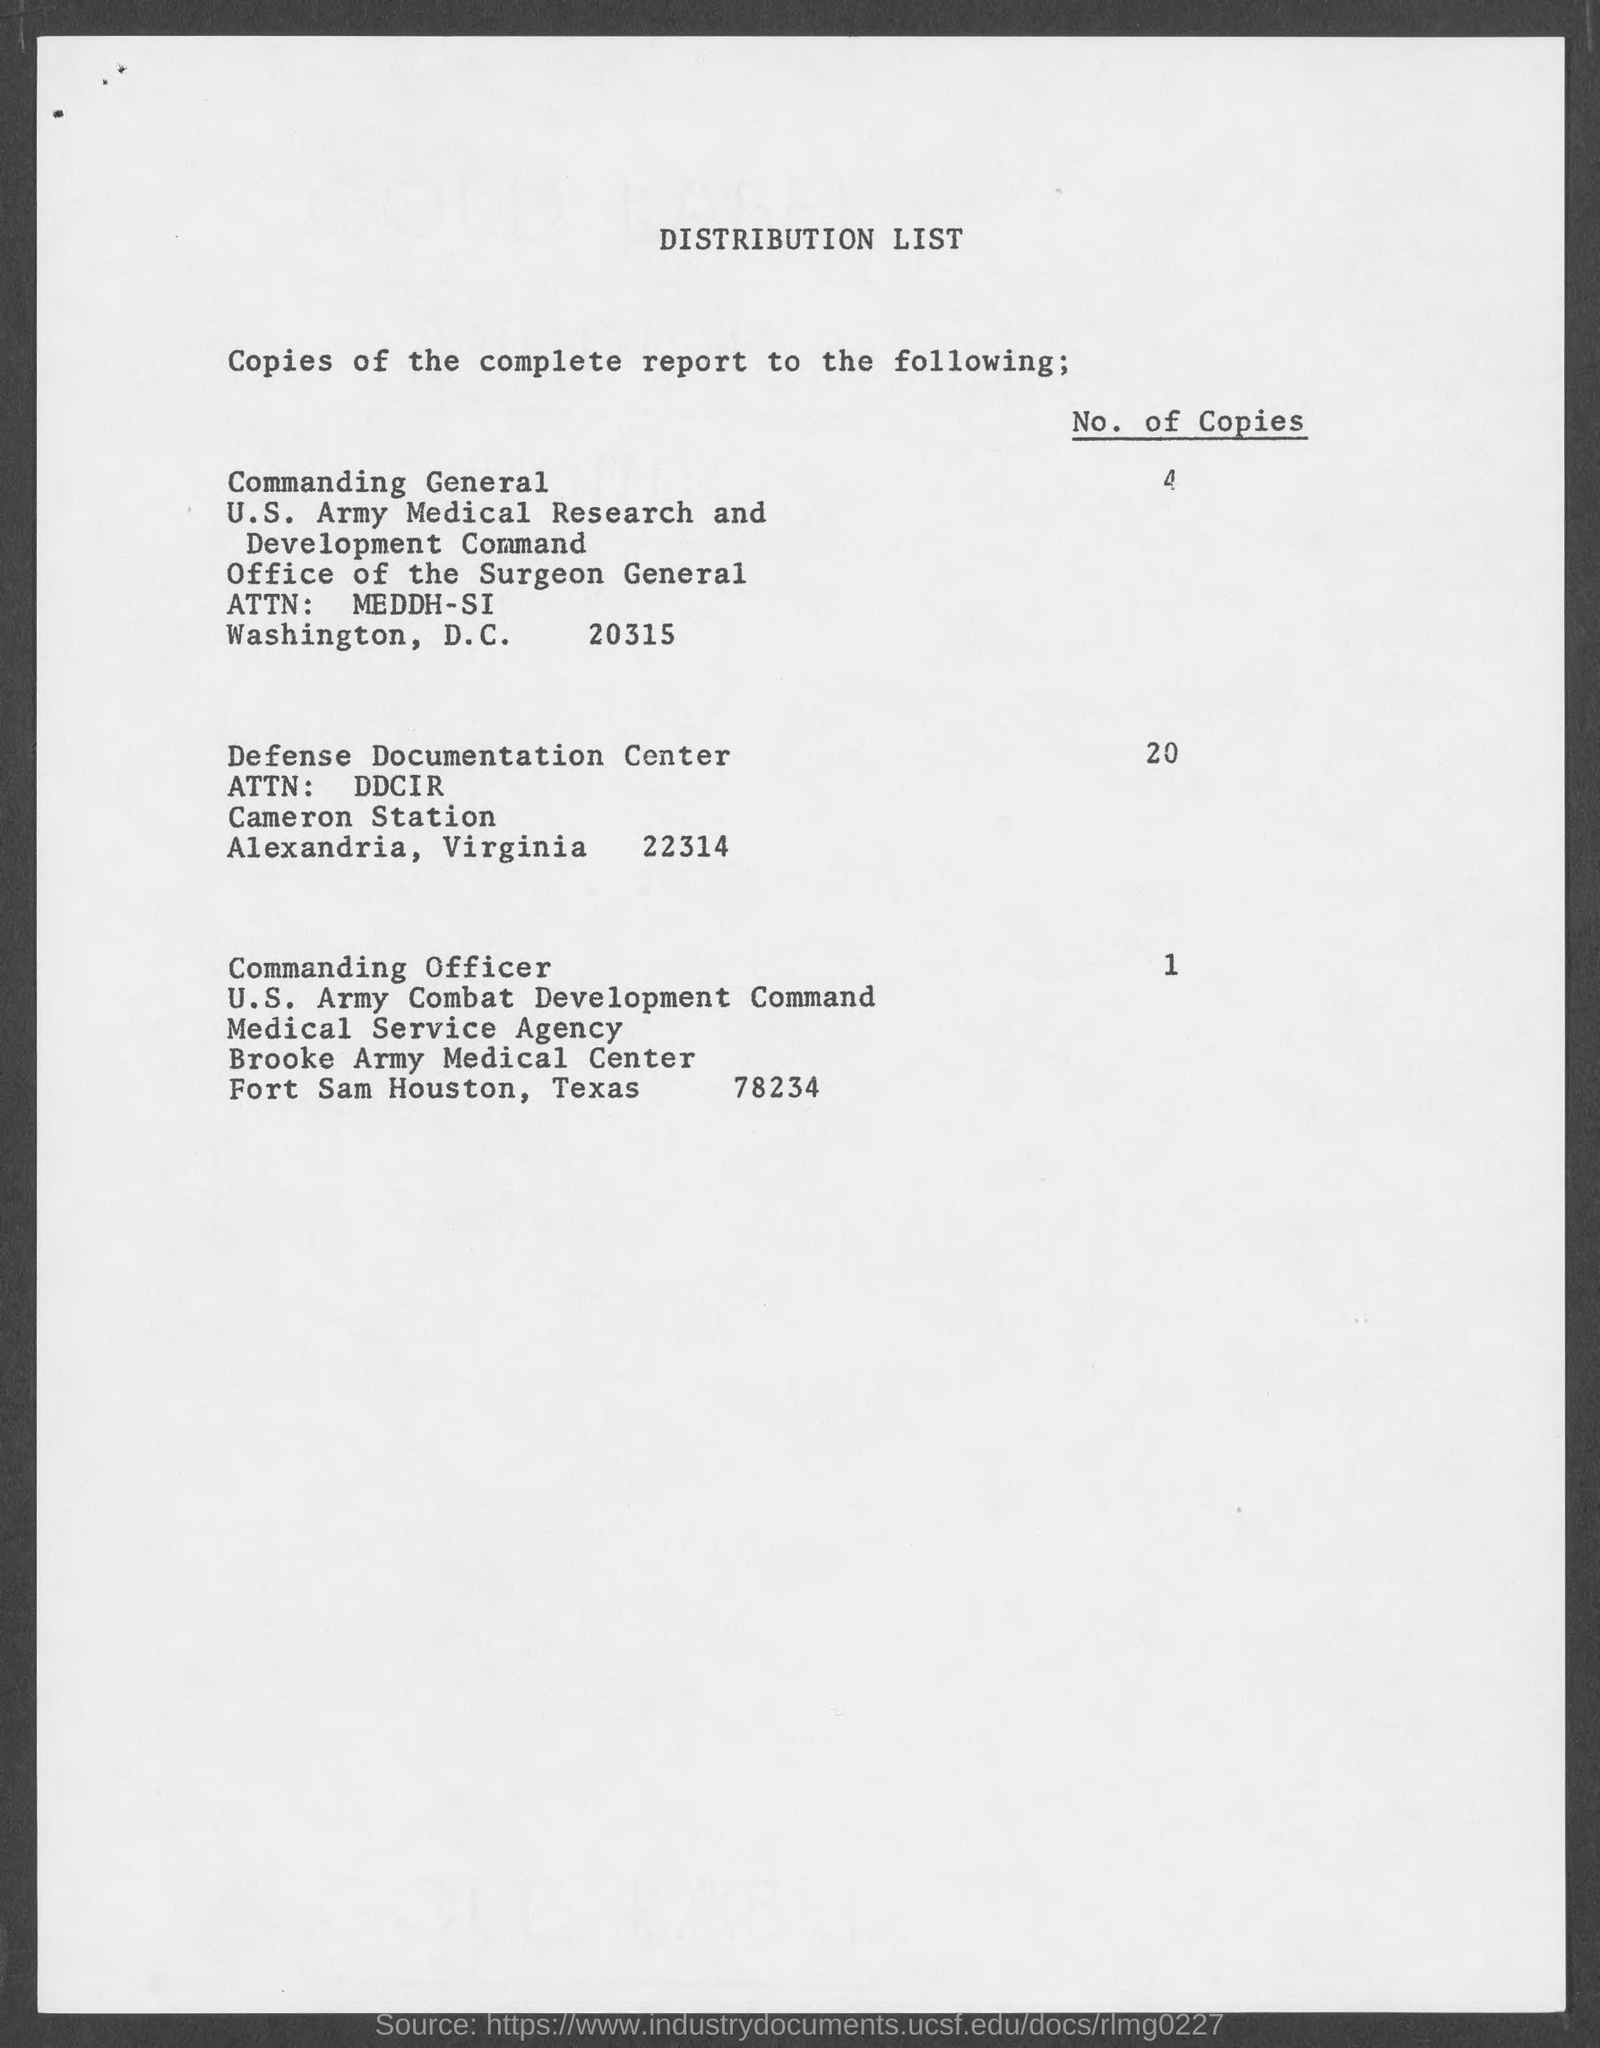how many no. of copies are distributed to Defense documentation center? Based on the document in the image, 20 copies of the complete report were distributed to the Defense Documentation Center. 